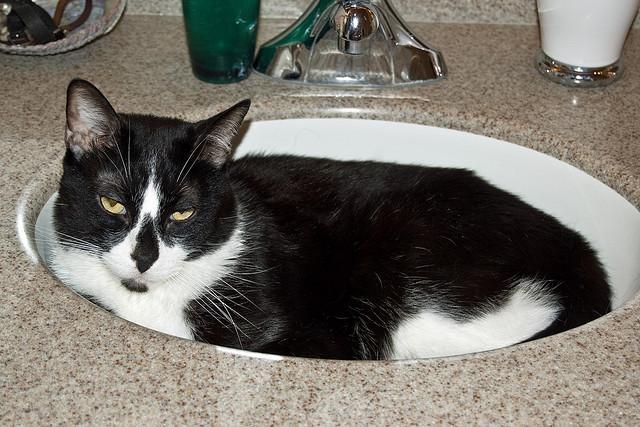What is this cat laying in?
Answer briefly. Sink. What color is the cat?
Quick response, please. Black and white. What color is the cup on the sink?
Answer briefly. Green. 